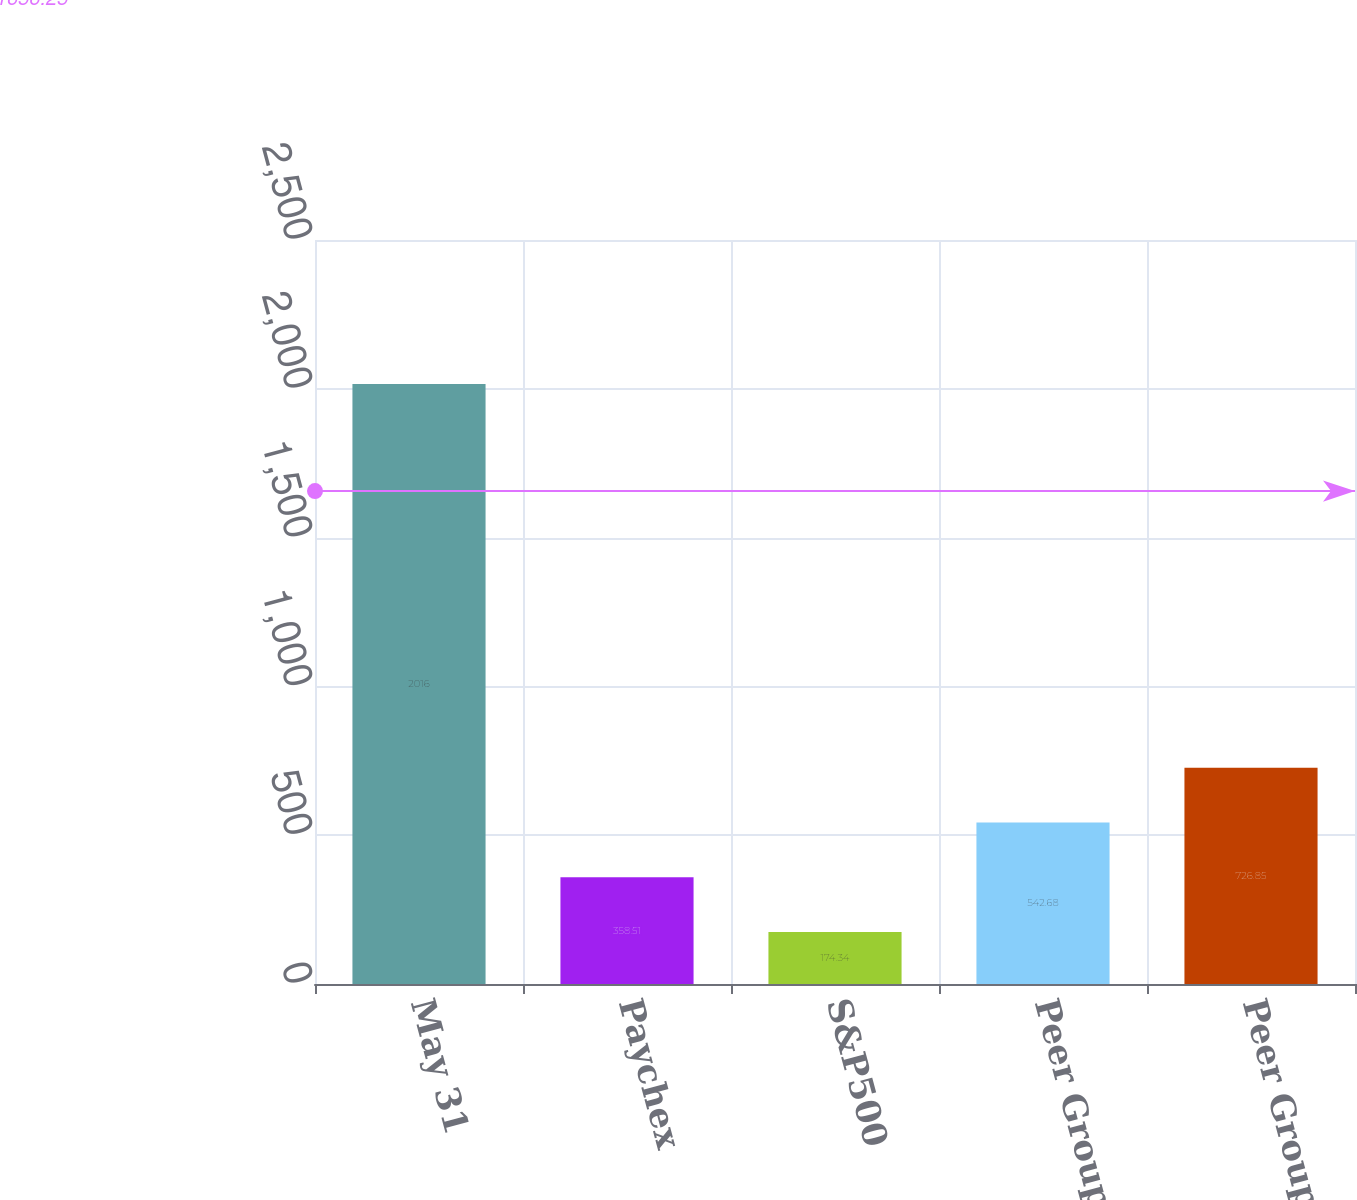<chart> <loc_0><loc_0><loc_500><loc_500><bar_chart><fcel>May 31<fcel>Paychex<fcel>S&P500<fcel>Peer Group-Old<fcel>Peer Group-New<nl><fcel>2016<fcel>358.51<fcel>174.34<fcel>542.68<fcel>726.85<nl></chart> 